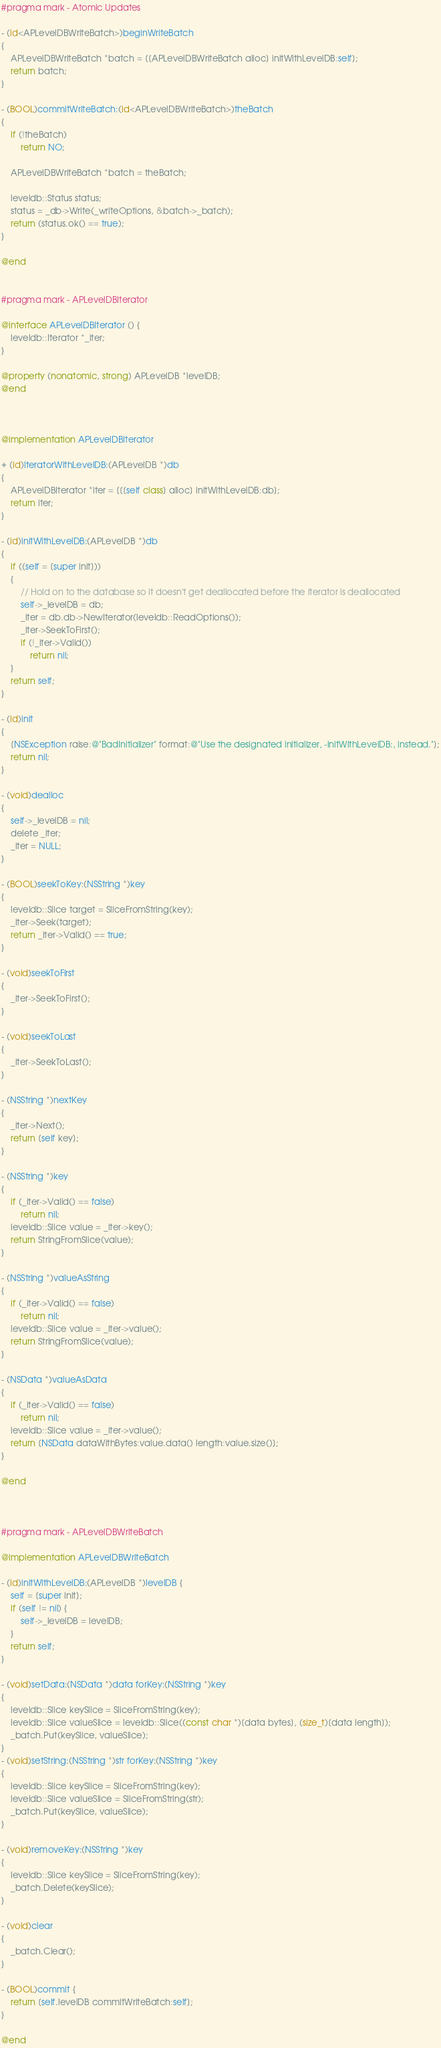<code> <loc_0><loc_0><loc_500><loc_500><_ObjectiveC_>
#pragma mark - Atomic Updates

- (id<APLevelDBWriteBatch>)beginWriteBatch
{
    APLevelDBWriteBatch *batch = [[APLevelDBWriteBatch alloc] initWithLevelDB:self];
    return batch;
}

- (BOOL)commitWriteBatch:(id<APLevelDBWriteBatch>)theBatch
{
    if (!theBatch)
        return NO;

    APLevelDBWriteBatch *batch = theBatch;

    leveldb::Status status;
    status = _db->Write(_writeOptions, &batch->_batch);
    return (status.ok() == true);
}

@end


#pragma mark - APLevelDBIterator

@interface APLevelDBIterator () {
    leveldb::Iterator *_iter;
}

@property (nonatomic, strong) APLevelDB *levelDB;
@end



@implementation APLevelDBIterator

+ (id)iteratorWithLevelDB:(APLevelDB *)db
{
    APLevelDBIterator *iter = [[[self class] alloc] initWithLevelDB:db];
    return iter;
}

- (id)initWithLevelDB:(APLevelDB *)db
{
    if ((self = [super init]))
    {
        // Hold on to the database so it doesn't get deallocated before the iterator is deallocated
        self->_levelDB = db;
        _iter = db.db->NewIterator(leveldb::ReadOptions());
        _iter->SeekToFirst();
        if (!_iter->Valid())
            return nil;
    }
    return self;
}

- (id)init
{
    [NSException raise:@"BadInitializer" format:@"Use the designated initializer, -initWithLevelDB:, instead."];
    return nil;
}

- (void)dealloc
{
    self->_levelDB = nil;
    delete _iter;
    _iter = NULL;
}

- (BOOL)seekToKey:(NSString *)key
{
    leveldb::Slice target = SliceFromString(key);
    _iter->Seek(target);
    return _iter->Valid() == true;
}

- (void)seekToFirst
{
    _iter->SeekToFirst();
}

- (void)seekToLast
{
    _iter->SeekToLast();
}

- (NSString *)nextKey
{
    _iter->Next();
    return [self key];
}

- (NSString *)key
{
    if (_iter->Valid() == false)
        return nil;
    leveldb::Slice value = _iter->key();
    return StringFromSlice(value);
}

- (NSString *)valueAsString
{
    if (_iter->Valid() == false)
        return nil;
    leveldb::Slice value = _iter->value();
    return StringFromSlice(value);
}

- (NSData *)valueAsData
{
    if (_iter->Valid() == false)
        return nil;
    leveldb::Slice value = _iter->value();
    return [NSData dataWithBytes:value.data() length:value.size()];
}

@end



#pragma mark - APLevelDBWriteBatch

@implementation APLevelDBWriteBatch

- (id)initWithLevelDB:(APLevelDB *)levelDB {
    self = [super init];
    if (self != nil) {
        self->_levelDB = levelDB;
    }
    return self;
}

- (void)setData:(NSData *)data forKey:(NSString *)key
{
    leveldb::Slice keySlice = SliceFromString(key);
    leveldb::Slice valueSlice = leveldb::Slice((const char *)[data bytes], (size_t)[data length]);
    _batch.Put(keySlice, valueSlice);
}
- (void)setString:(NSString *)str forKey:(NSString *)key
{
    leveldb::Slice keySlice = SliceFromString(key);
    leveldb::Slice valueSlice = SliceFromString(str);
    _batch.Put(keySlice, valueSlice);
}

- (void)removeKey:(NSString *)key
{
    leveldb::Slice keySlice = SliceFromString(key);
    _batch.Delete(keySlice);
}

- (void)clear
{
    _batch.Clear();
}

- (BOOL)commit {
    return [self.levelDB commitWriteBatch:self];
}

@end

</code> 